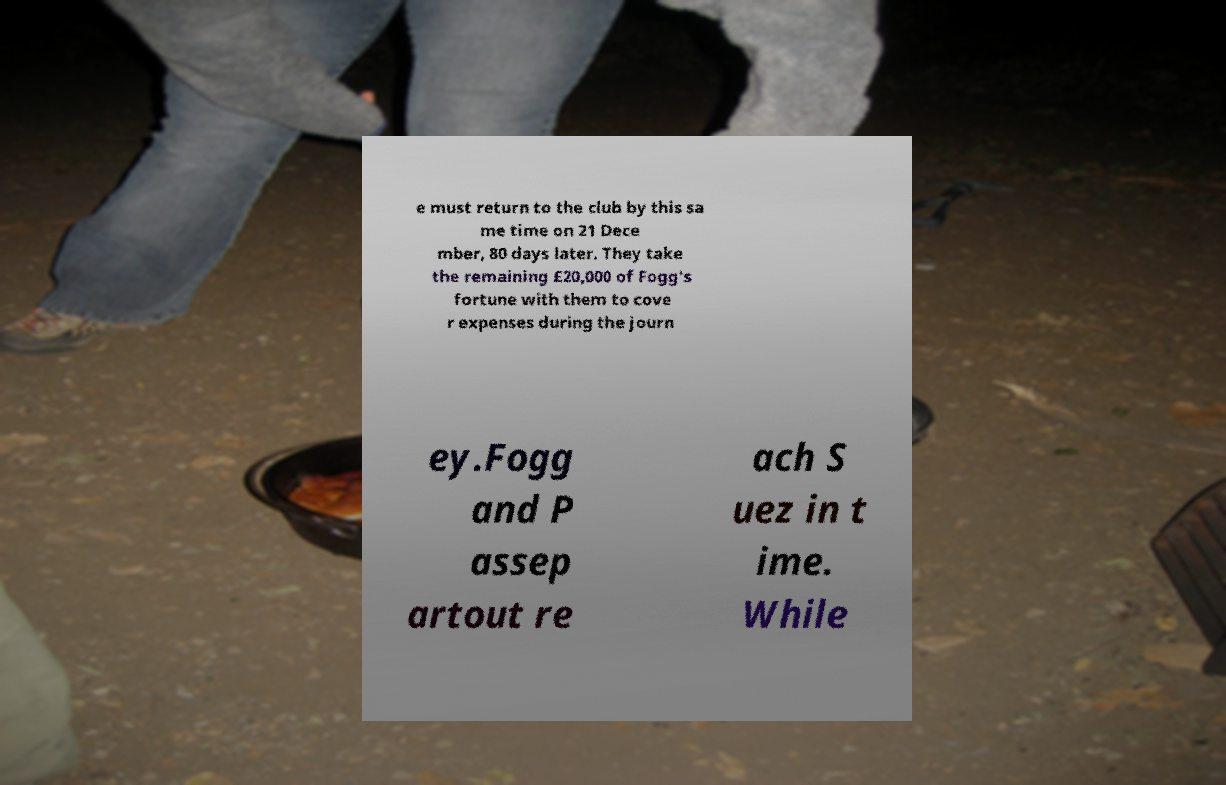Could you assist in decoding the text presented in this image and type it out clearly? e must return to the club by this sa me time on 21 Dece mber, 80 days later. They take the remaining £20,000 of Fogg's fortune with them to cove r expenses during the journ ey.Fogg and P assep artout re ach S uez in t ime. While 